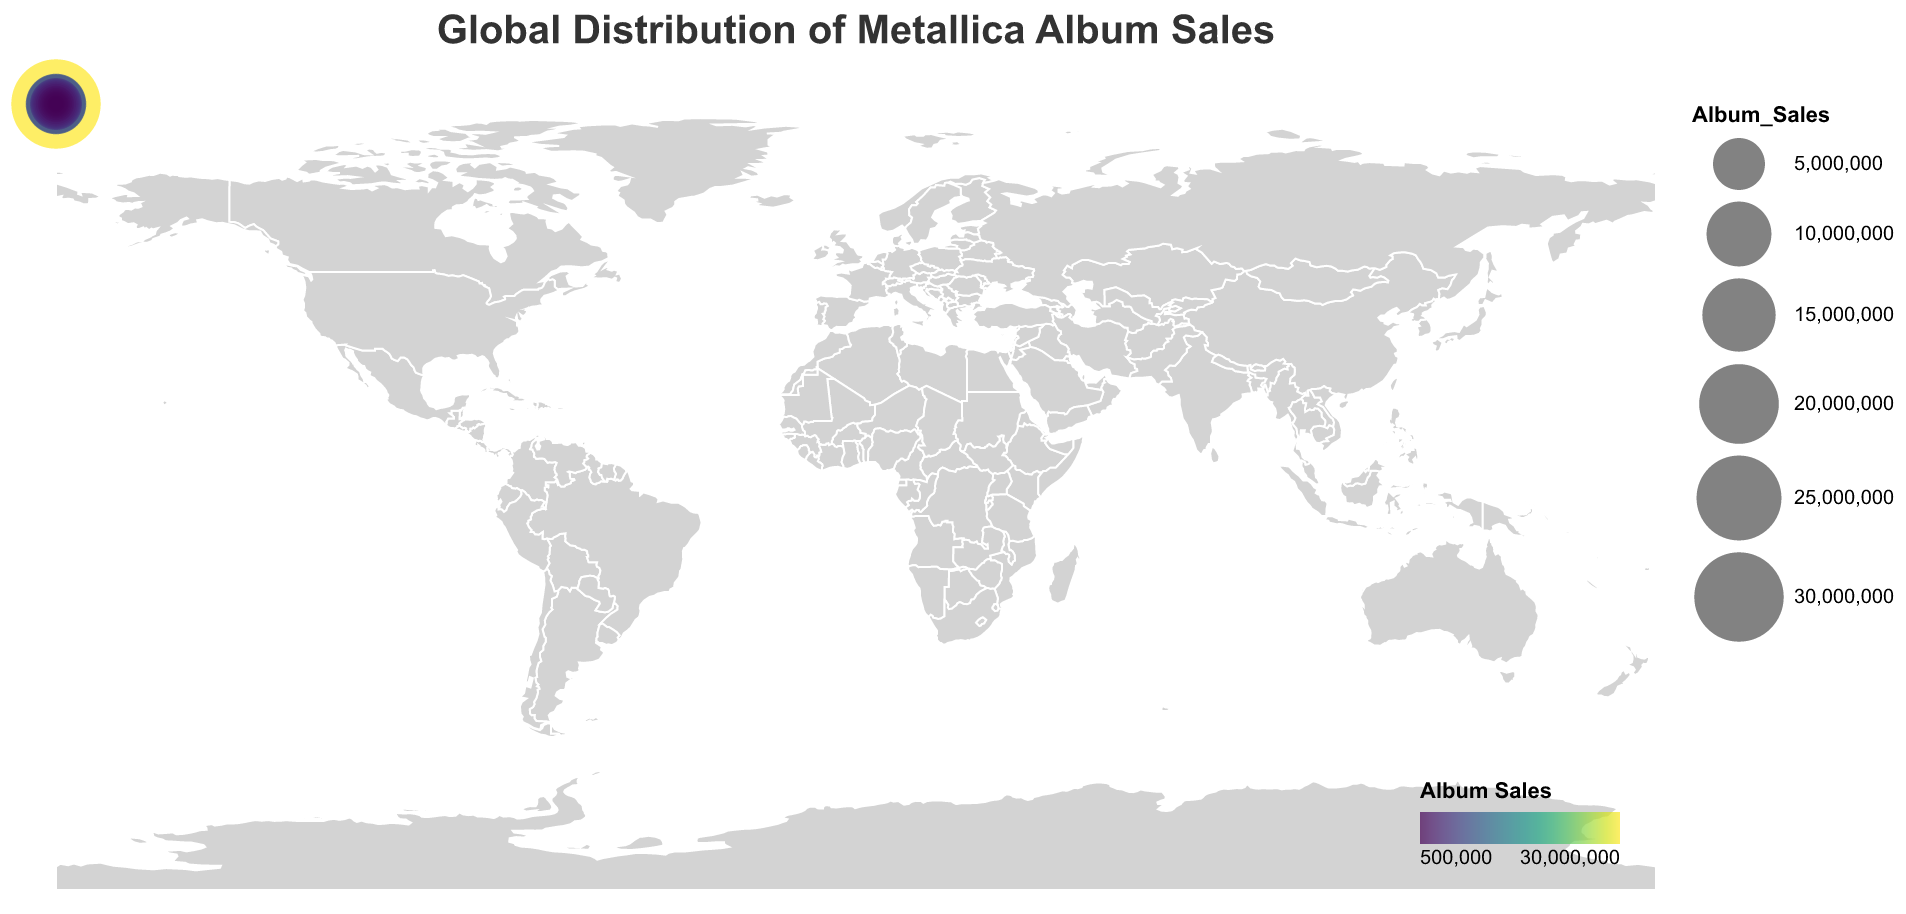What is the total album sales for Metallica in the United States? The circle size and tooltip for the United States indicate the album sales. According to the tooltip, the United States has 30,000,000 album sales.
Answer: 30,000,000 Which country has the second-highest album sales of Metallica albums? By reading the circle sizes and tooltips, Germany has the second-largest circle with album sales of 8,000,000.
Answer: Germany How many countries have Metallica album sales greater than 5,000,000? From the data and tooltips, the countries with sales greater than 5,000,000 are the United States, Germany, United Kingdom, and Canada. There are 4 countries in total.
Answer: 4 What is the combined album sales of Metallica in France and Brazil? France has 3,500,000 and Brazil has 3,000,000 album sales. Adding these gives 3,500,000 + 3,000,000 = 6,500,000.
Answer: 6,500,000 Which country has the smallest album sales for Metallica? According to the tooltip data and the circle sizes, Belgium has the smallest album sales with 500,000.
Answer: Belgium What's the difference in album sales between the United States and the United Kingdom? The United States has 30,000,000 album sales and the United Kingdom has 7,500,000. The difference is 30,000,000 - 7,500,000 = 22,500,000.
Answer: 22,500,000 How do the album sales in Japan compare to those in Australia? According to the circle size and tooltips, Japan has 4,000,000 album sales, while Australia has 4,500,000. Australia has higher album sales.
Answer: Australia What is the total album sales shown on the map? Sum all the album sales values provided in the tooltip data: 30,000,000 (US) + 8,000,000 (Germany) + 7,500,000 (UK) + 5,000,000 (Canada) + 4,500,000 (Australia) + 4,000,000 (Japan) + 3,500,000 (France) + 3,000,000 (Brazil) + 2,500,000 (Sweden) + 2,000,000 (Mexico) + 1,800,000 (Netherlands) + 1,500,000 (Spain) + 1,400,000 (Italy) + 1,200,000 (Argentina) + 1,000,000 (Russia) + 900,000 (Finland) + 800,000 (Norway) + 700,000 (Denmark) + 600,000 (Poland) + 500,000 (Belgium). The total is 79,400,000.
Answer: 79,400,000 